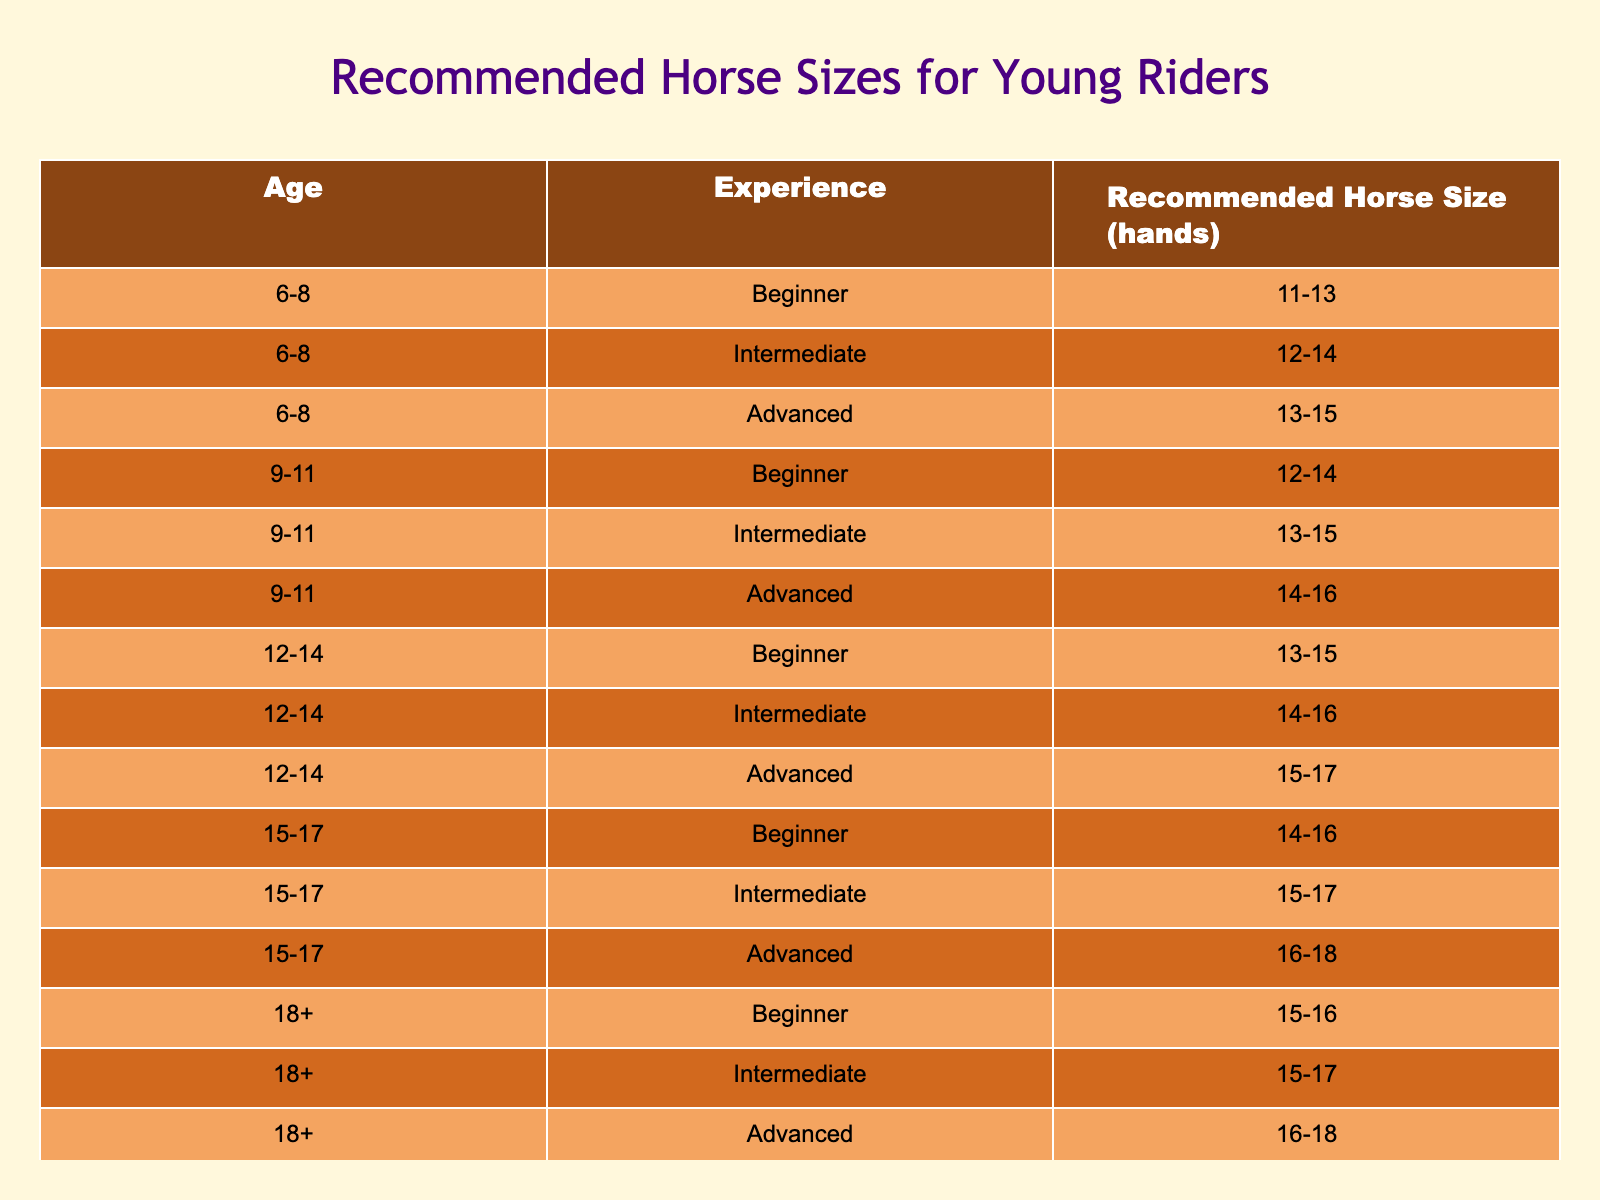What is the recommended horse size for a beginner aged 9-11? According to the table, for a beginner rider in the age range of 9-11, the recommended horse size is 12-14 hands.
Answer: 12-14 Is there a recommended horse size for intermediate riders aged 15-17? Yes, for intermediate riders aged 15-17, the table states that the recommended horse size is 15-17 hands.
Answer: Yes For an advanced rider aged 12-14, what is the height range of the recommended horse size? The table indicates that for advanced riders aged 12-14, the recommended horse size is between 15-17 hands.
Answer: 15-17 Do beginners aged 6-8 have a different recommended horse size compared to beginners aged 15-17? Yes, for beginners aged 6-8, the size is 11-13 hands, while for beginners aged 15-17, the size is 14-16 hands.
Answer: Yes What is the difference in recommended horse size between an advanced rider aged 9-11 and an advanced rider aged 15-17? For advanced riders aged 9-11, the size is 14-16 hands, while for advanced riders aged 15-17, the size is 16-18 hands. The difference is 2 hands.
Answer: 2 hands For a beginner aged 18 and over, what is the median of the recommended horse sizes? The table shows that for beginners aged 18+, the sizes are 15-16 hands. Since there is only one interval, the median is the same as the range, which is 15-16 hands.
Answer: 15-16 If a child aged 10 has intermediate experience, what horse size should be recommended? From the table, for a child aged 9-11 with intermediate experience, the recommended horse size is 13-15 hands. Therefore, a 10-year-old will fit within this recommendation.
Answer: 13-15 Are there any age groups where the recommended horse size does not increase with experience? For riders aged 6-8, while the horse size does increase with experience, all categories only recommend sizes that range between 11-15 hands, which shows less variability compared to older age groups.
Answer: Yes What is the average horse size recommended for all advanced riders? The advanced riders have recommended sizes of 13-15, 14-16, 15-17, 16-18. To find the average, we can sum the midpoints of these ranges: (14 + 15 + 16 + 17) / 4 = 15.5 hands.
Answer: 15.5 hands Is it true that all recommended horse sizes are above 11 hands? Yes, the table shows that the smallest recommended horse size is 11 hands for beginners aged 6-8.
Answer: Yes 